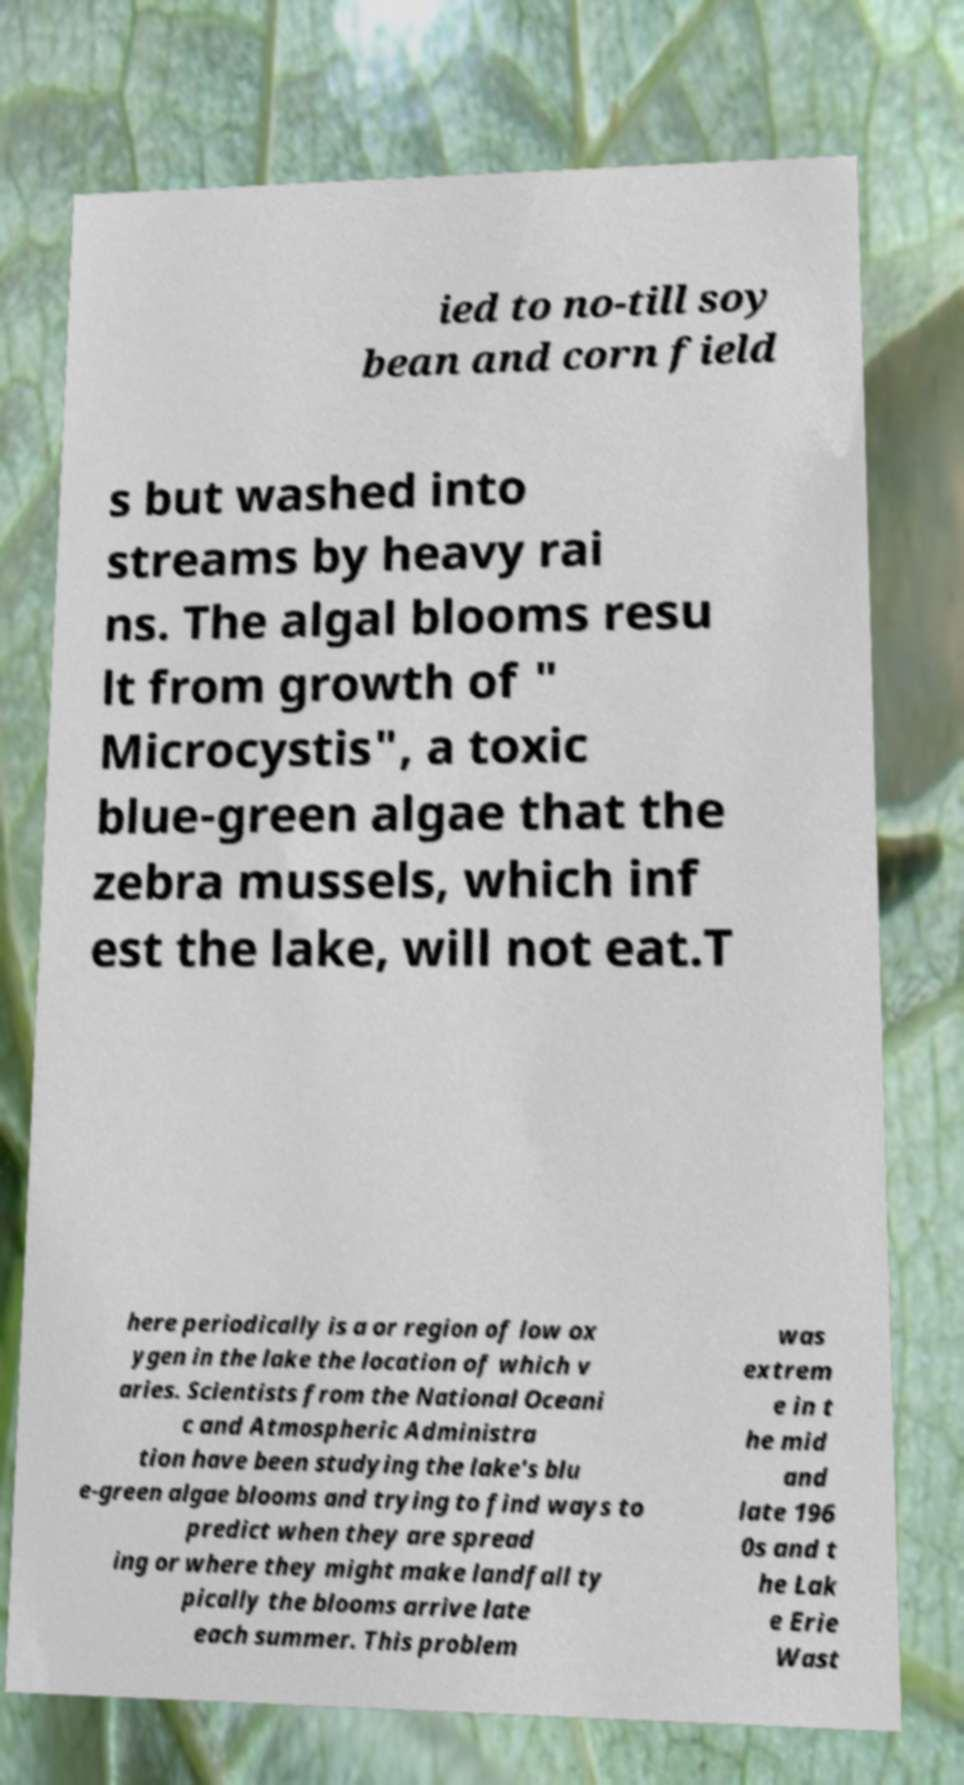Please identify and transcribe the text found in this image. ied to no-till soy bean and corn field s but washed into streams by heavy rai ns. The algal blooms resu lt from growth of " Microcystis", a toxic blue-green algae that the zebra mussels, which inf est the lake, will not eat.T here periodically is a or region of low ox ygen in the lake the location of which v aries. Scientists from the National Oceani c and Atmospheric Administra tion have been studying the lake's blu e-green algae blooms and trying to find ways to predict when they are spread ing or where they might make landfall ty pically the blooms arrive late each summer. This problem was extrem e in t he mid and late 196 0s and t he Lak e Erie Wast 